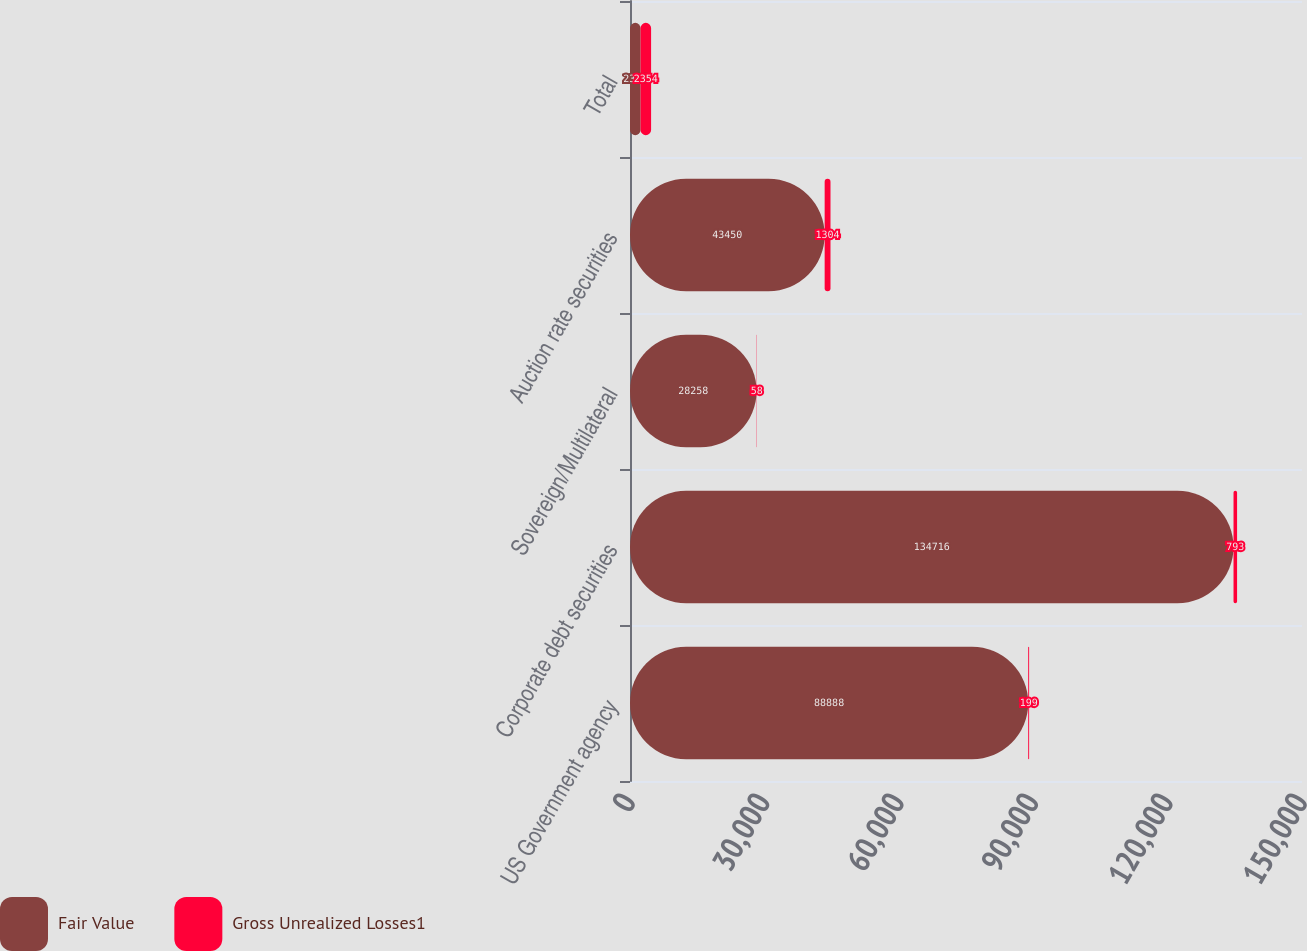<chart> <loc_0><loc_0><loc_500><loc_500><stacked_bar_chart><ecel><fcel>US Government agency<fcel>Corporate debt securities<fcel>Sovereign/Multilateral<fcel>Auction rate securities<fcel>Total<nl><fcel>Fair Value<fcel>88888<fcel>134716<fcel>28258<fcel>43450<fcel>2354<nl><fcel>Gross Unrealized Losses1<fcel>199<fcel>793<fcel>58<fcel>1304<fcel>2354<nl></chart> 